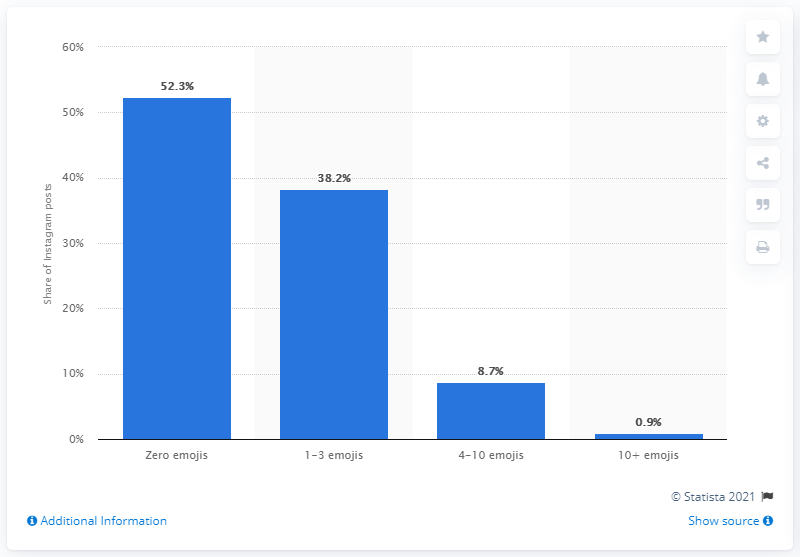List a handful of essential elements in this visual. In June 2019, 47.8% of Instagram users included at least one emoji in their posts, indicating the growing popularity of emojis in online communication. Approximately 52.3% of posts on Twitter did not contain any emojis. According to a survey conducted in June 2019, only 52.3% of people do not use Emojis in their Instagram posts. 